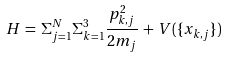Convert formula to latex. <formula><loc_0><loc_0><loc_500><loc_500>H \, = \, \Sigma ^ { N } _ { j = 1 } \Sigma _ { k = 1 } ^ { 3 } \frac { p ^ { 2 } _ { k , j } } { 2 m _ { j } } \, + \, V ( \{ x _ { k , j } \} )</formula> 